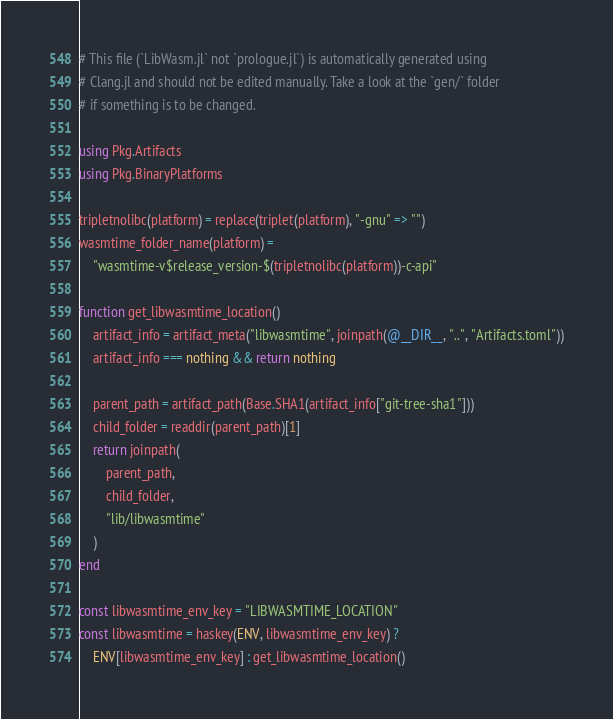Convert code to text. <code><loc_0><loc_0><loc_500><loc_500><_Julia_># This file (`LibWasm.jl` not `prologue.jl`) is automatically generated using
# Clang.jl and should not be edited manually. Take a look at the `gen/` folder
# if something is to be changed.

using Pkg.Artifacts
using Pkg.BinaryPlatforms

tripletnolibc(platform) = replace(triplet(platform), "-gnu" => "")
wasmtime_folder_name(platform) =
    "wasmtime-v$release_version-$(tripletnolibc(platform))-c-api"

function get_libwasmtime_location()
    artifact_info = artifact_meta("libwasmtime", joinpath(@__DIR__, "..", "Artifacts.toml"))
    artifact_info === nothing && return nothing

    parent_path = artifact_path(Base.SHA1(artifact_info["git-tree-sha1"]))
    child_folder = readdir(parent_path)[1]
    return joinpath(
        parent_path,
        child_folder,
        "lib/libwasmtime"
    )
end

const libwasmtime_env_key = "LIBWASMTIME_LOCATION"
const libwasmtime = haskey(ENV, libwasmtime_env_key) ?
    ENV[libwasmtime_env_key] : get_libwasmtime_location()
</code> 